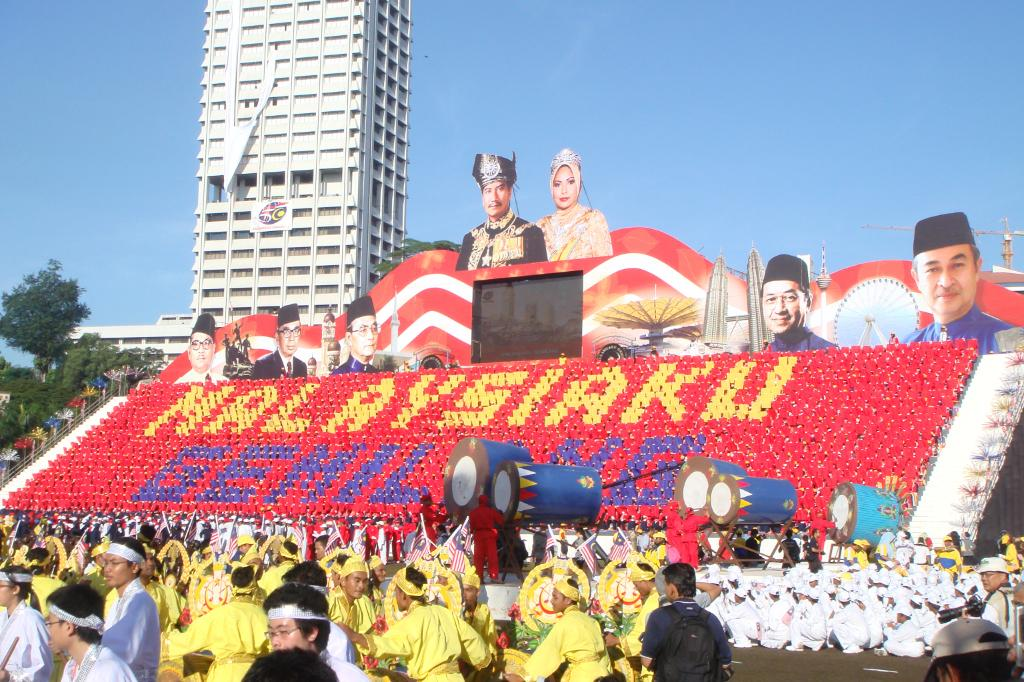What is happening with the group of people in the image? The group of people is on the ground in the image. What can be seen in the image besides the group of people? There are flags, posters, a building, trees, and some objects in the image. What is the background of the image? The sky is visible in the background of the image. Can you see an orange in the image? There is no mention of an orange in the image. 